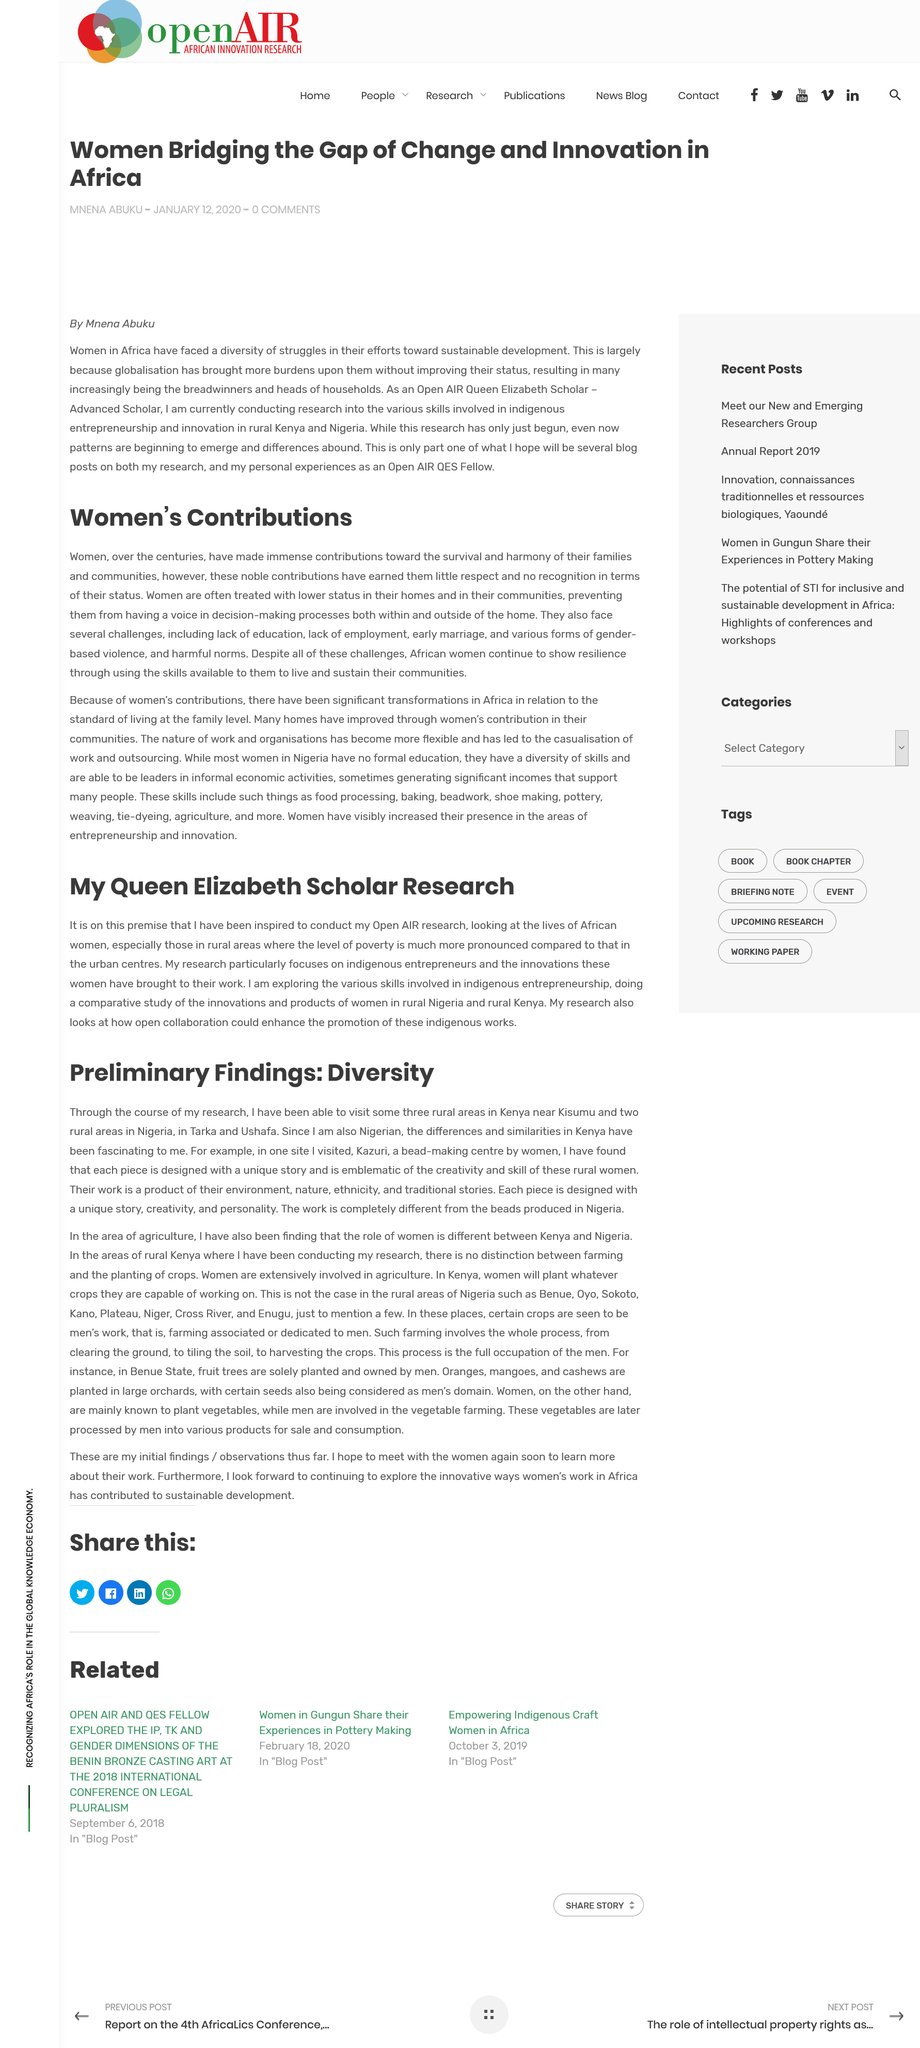Give some essential details in this illustration. African women are denied a voice in decision-making due to their lower status in homes and communities, resulting in systemic discrimination and marginalization. African women's contributions are not properly recognized in their homes and communities, where they are often treated with lower status. Research is currently taking place in Kenya and Nigeria. The title of this document is Preliminary Findings: Diversity in the Workplace. The comparative study of innovations and products developed by women in rural Kenya and Nigeria, as stated in the article, highlights the similarities and differences between the two countries in promoting women's economic empowerment. 